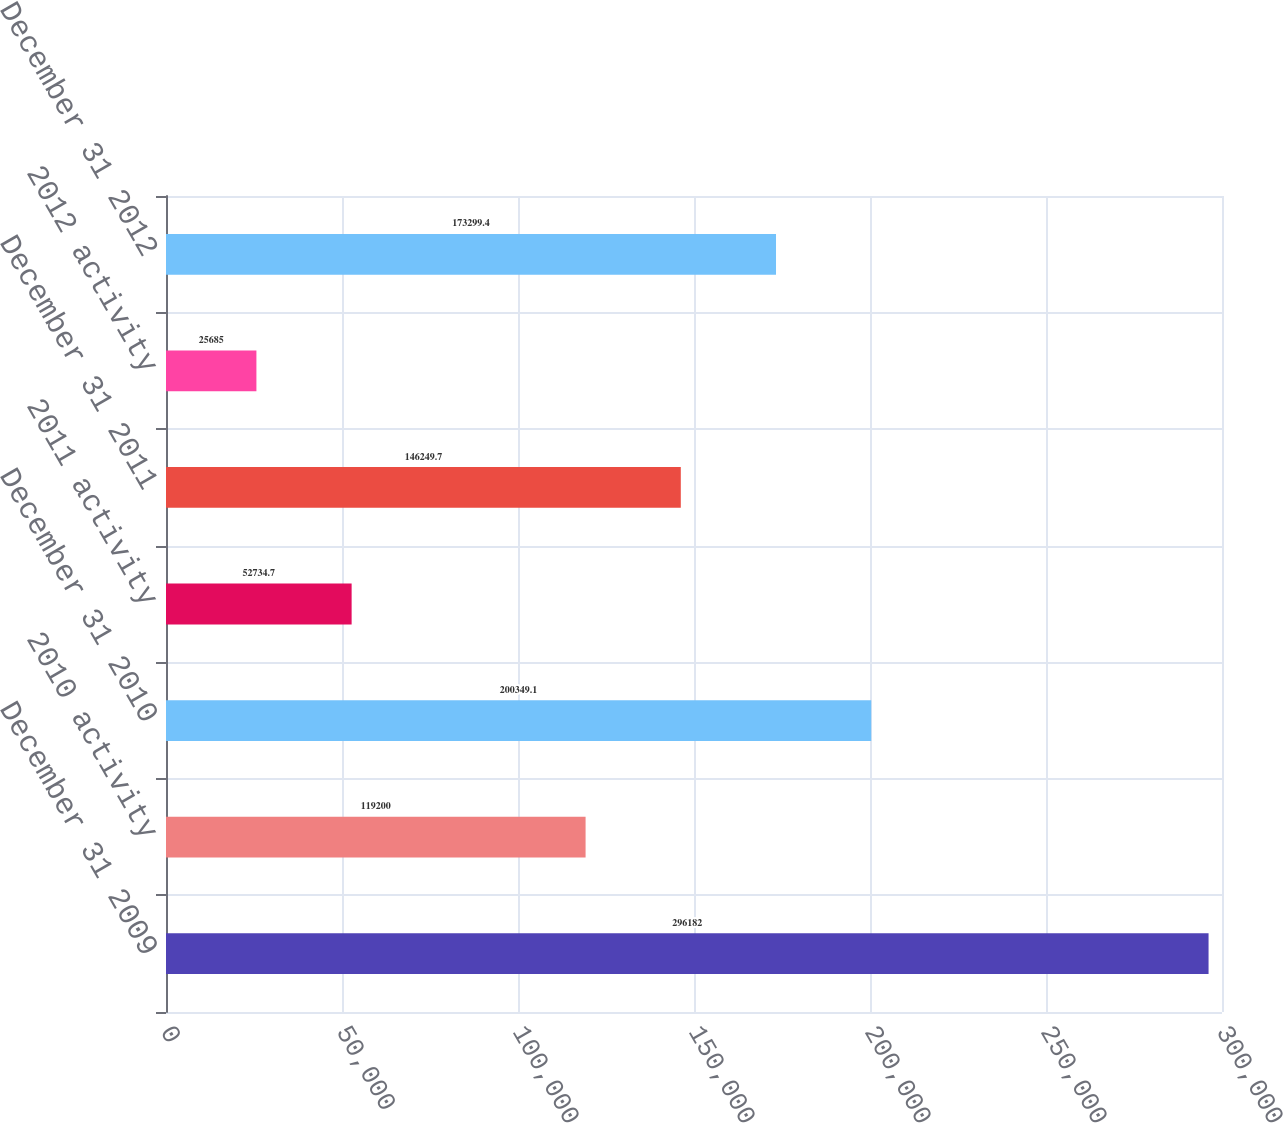Convert chart to OTSL. <chart><loc_0><loc_0><loc_500><loc_500><bar_chart><fcel>December 31 2009<fcel>2010 activity<fcel>December 31 2010<fcel>2011 activity<fcel>December 31 2011<fcel>2012 activity<fcel>December 31 2012<nl><fcel>296182<fcel>119200<fcel>200349<fcel>52734.7<fcel>146250<fcel>25685<fcel>173299<nl></chart> 